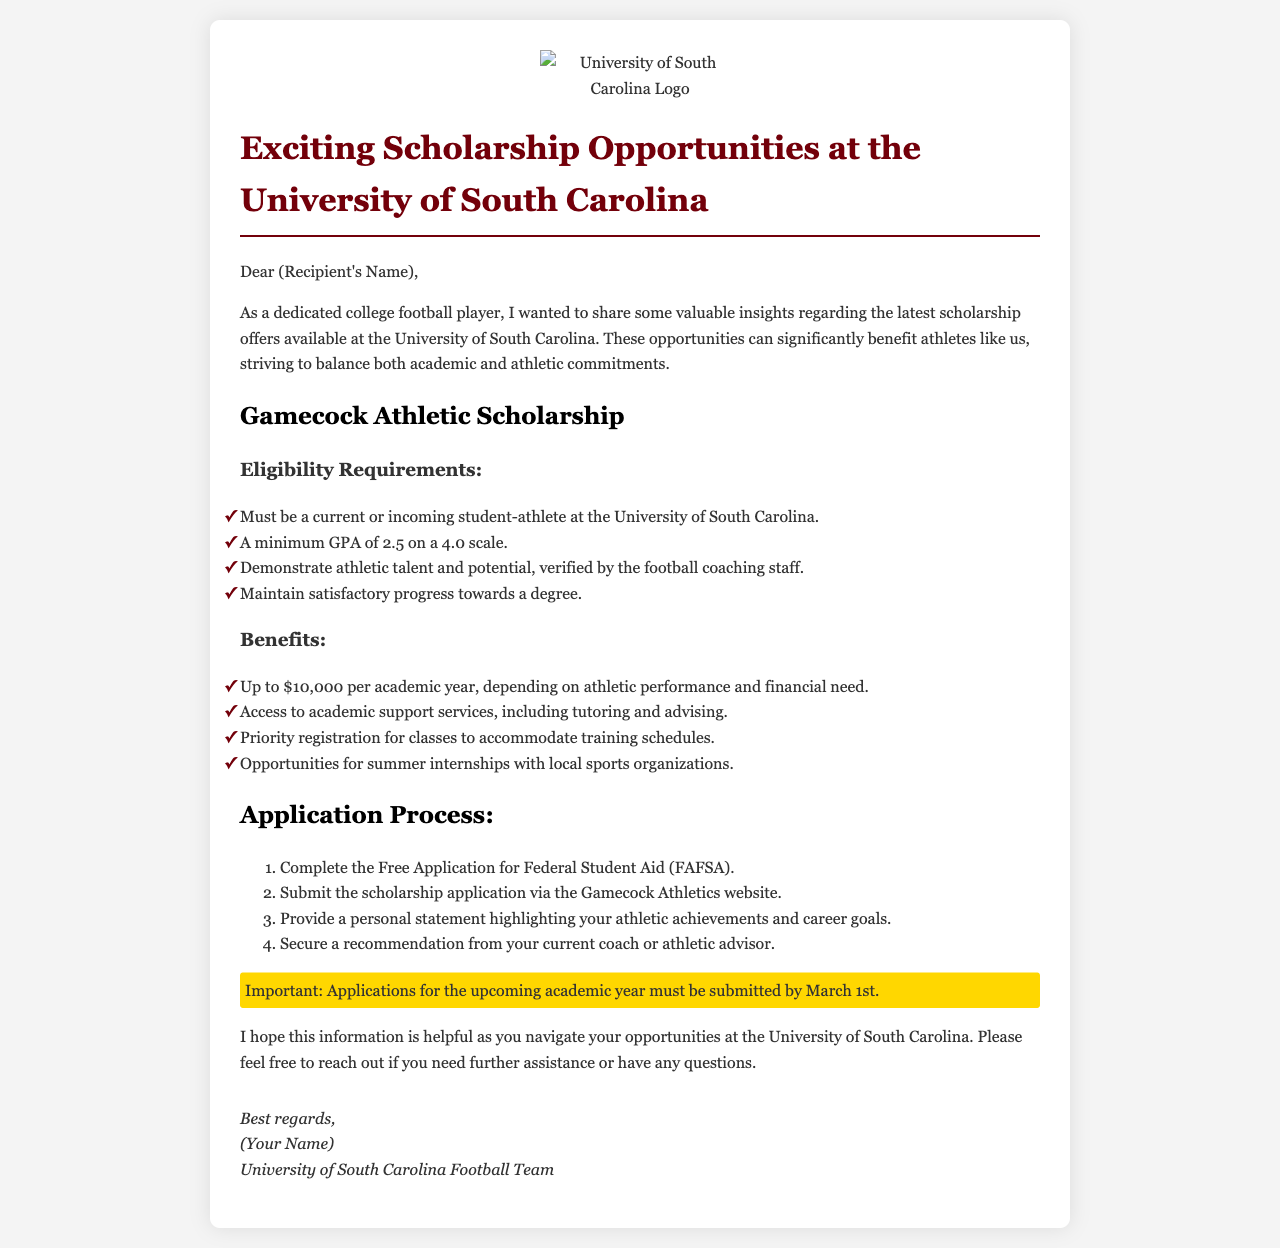What is the scholarship called? The scholarship is specifically named in the document as the "Gamecock Athletic Scholarship."
Answer: Gamecock Athletic Scholarship What is the minimum GPA requirement? The document states that a minimum GPA of 2.5 on a 4.0 scale is required.
Answer: 2.5 How much can the scholarship offer per academic year? The maximum financial support per academic year is detailed as "up to $10,000."
Answer: Up to $10,000 What is the deadline for scholarship applications? The document specifies that applications must be submitted by "March 1st."
Answer: March 1st What is one benefit listed in the document? The document lists several benefits, one of which is "access to academic support services."
Answer: Access to academic support services What needs to be submitted along with the scholarship application? Apart from the application, a "personal statement" highlighting achievements is required.
Answer: Personal statement What is a requirement regarding athletic talent? The scholarship requires that applicants "demonstrate athletic talent and potential."
Answer: Demonstrate athletic talent and potential How many steps are in the application process? The application process consists of "4" steps as outlined in the document.
Answer: 4 What is a specific group mentioned in the eligibility requirements? The document specifies that applicants must be a "current or incoming student-athlete."
Answer: Current or incoming student-athlete 